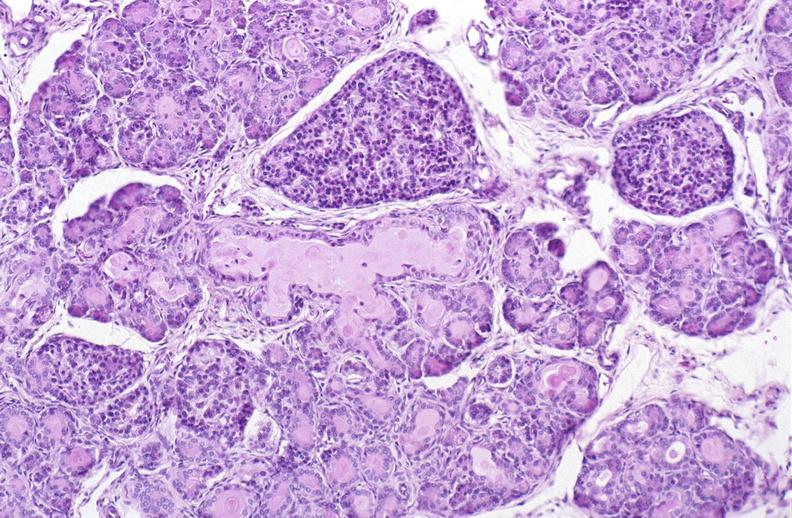where is this?
Answer the question using a single word or phrase. Pancreas 